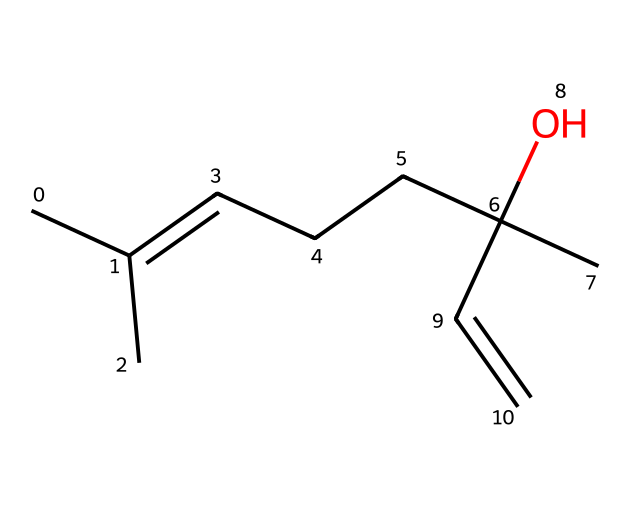What is the molecular formula of linalool? To determine the molecular formula from the SMILES representation (CC(C)=CCCC(C)(O)C=C), we count the number of each type of atom present. The carbon atoms (C) total 10, hydrogen atoms (H) total 18, and there is one oxygen atom (O). Thus, the molecular formula is C10H18O.
Answer: C10H18O How many double bonds are present in this compound? By examining the SMILES representation, we notice the C=C part in the structure. This indicates one double bond in the molecule. There are no other occurrences of '=' that would suggest additional double bonds.
Answer: 1 Is linalool saturated or unsaturated? The presence of a double bond (C=C) indicates that this compound is unsaturated, as saturated compounds contain only single bonds between carbon atoms.
Answer: unsaturated What functional group is present in linalool? In the SMILES representation, the (O) attached to a carbon indicates the presence of a hydroxyl group (-OH), which is characteristic of alcohols. Therefore, linalool contains an alcohol functional group.
Answer: alcohol How many tertiary carbon atoms are in linalool? A tertiary carbon is bonded to three other carbon atoms. In the provided structure, we find two carbon atoms that are each connected to three other carbons: one at the isopropyl group and another at the carbon bearing the hydroxyl group. Thus, there are two tertiary carbons.
Answer: 2 Which part of the molecule contributes to its fragrance? Terpenes, including linalool, are known for their aromatic properties, primarily due to the hydrocarbon chain and the alcohol functional group. The structure contains a long carbon chain and hydroxyl group, which together give it a pleasant floral scent.
Answer: hydrocarbon chain and hydroxyl group 